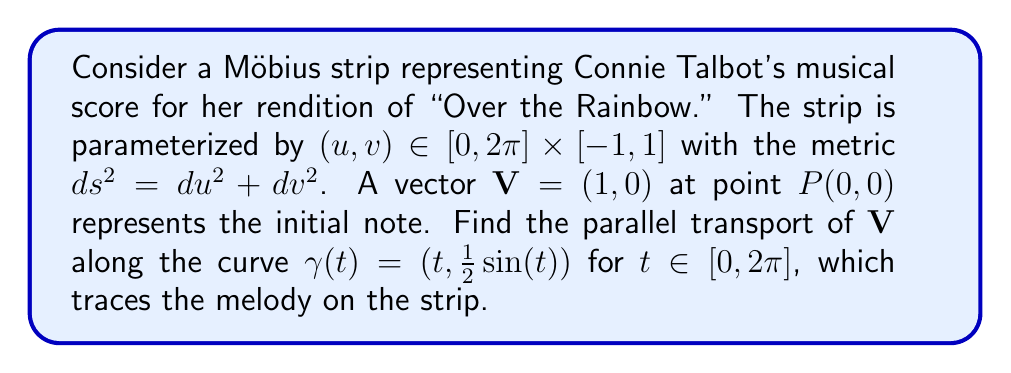Can you solve this math problem? To solve this problem, we'll follow these steps:

1) First, we need to calculate the Christoffel symbols for the Möbius strip. Given the metric $ds^2 = du^2 + dv^2$, all Christoffel symbols are zero.

2) The parallel transport equation is:

   $$\frac{dV^i}{dt} + \Gamma^i_{jk} \frac{dx^j}{dt} V^k = 0$$

   where $V^i$ are the components of the vector being transported, $\frac{dx^j}{dt}$ are the components of the tangent vector to the curve, and $\Gamma^i_{jk}$ are the Christoffel symbols.

3) Since all Christoffel symbols are zero, our equation simplifies to:

   $$\frac{dV^i}{dt} = 0$$

4) This means that the components of the vector remain constant along the curve.

5) Our initial vector is $\mathbf{V} = (1,0)$, so it will remain $(1,0)$ throughout the transport.

6) However, we need to be careful at the end of the curve. After a full rotation around the Möbius strip (at $t=2\pi$), we've actually returned to the opposite side of where we started.

7) On a Möbius strip, a vector that makes a full trip around the strip comes back reversed. So after parallel transport along the entire curve, our vector will be $(-1,0)$.

This result musically represents how the melody of "Over the Rainbow" in Connie Talbot's rendition comes full circle, but with a twist at the end, much like the structure of a Möbius strip.
Answer: The parallel transport of $\mathbf{V} = (1,0)$ along $\gamma(t) = (t, \frac{1}{2}\sin(t))$ for $t \in [0,2\pi]$ on the Möbius strip results in $\mathbf{V}_{\text{final}} = (-1,0)$. 